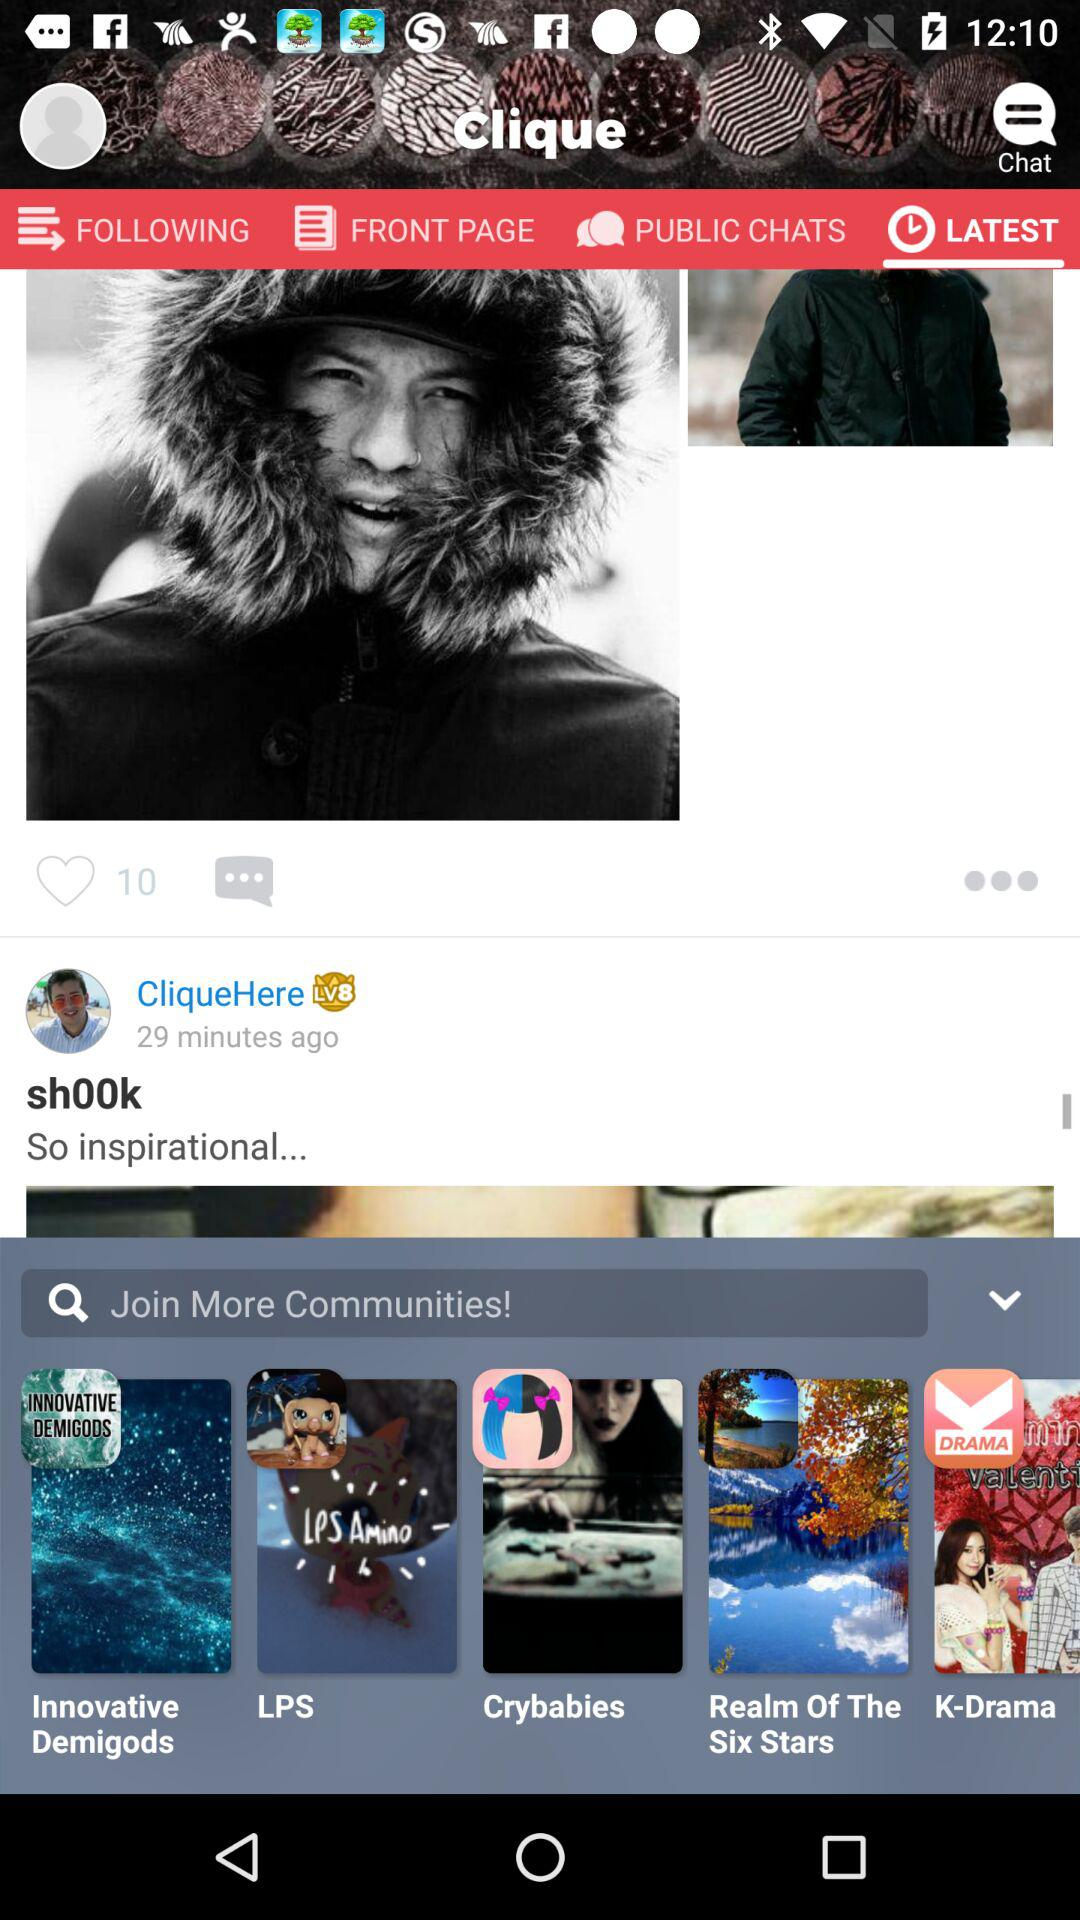How many more minutes ago was the post made than the time shown in the top right corner?
Answer the question using a single word or phrase. 29 